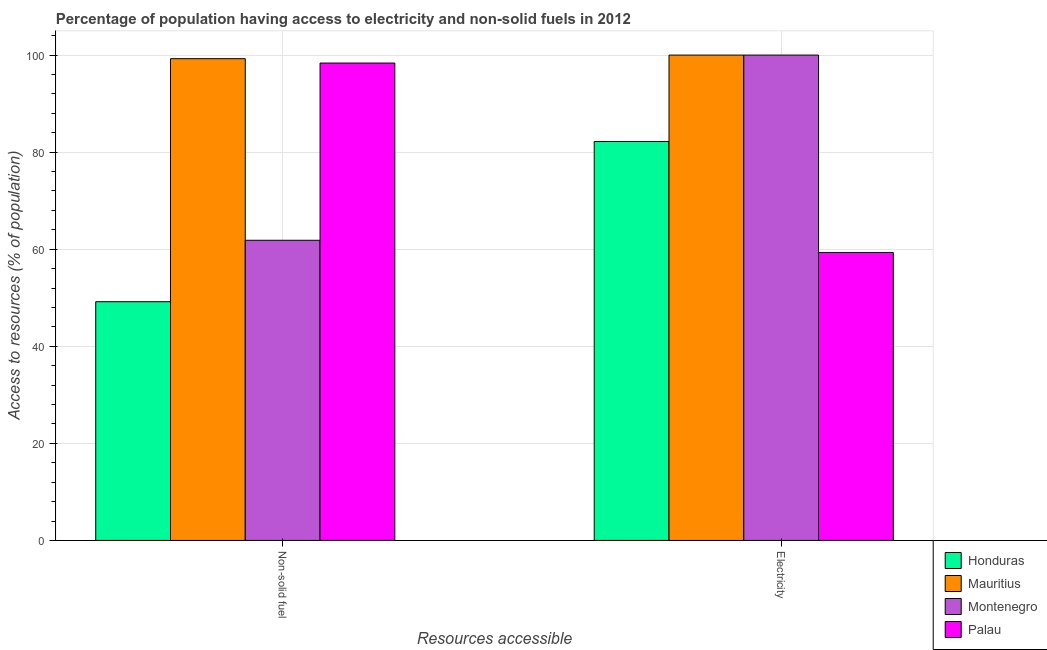How many groups of bars are there?
Give a very brief answer. 2. Are the number of bars per tick equal to the number of legend labels?
Offer a very short reply. Yes. Are the number of bars on each tick of the X-axis equal?
Your response must be concise. Yes. How many bars are there on the 1st tick from the right?
Ensure brevity in your answer.  4. What is the label of the 2nd group of bars from the left?
Your answer should be very brief. Electricity. What is the percentage of population having access to non-solid fuel in Honduras?
Ensure brevity in your answer.  49.19. Across all countries, what is the minimum percentage of population having access to electricity?
Make the answer very short. 59.33. In which country was the percentage of population having access to electricity maximum?
Offer a very short reply. Mauritius. In which country was the percentage of population having access to electricity minimum?
Give a very brief answer. Palau. What is the total percentage of population having access to electricity in the graph?
Make the answer very short. 341.53. What is the difference between the percentage of population having access to non-solid fuel in Montenegro and that in Honduras?
Your response must be concise. 12.66. What is the difference between the percentage of population having access to non-solid fuel in Palau and the percentage of population having access to electricity in Honduras?
Provide a succinct answer. 16.16. What is the average percentage of population having access to electricity per country?
Provide a short and direct response. 85.38. What is the difference between the percentage of population having access to non-solid fuel and percentage of population having access to electricity in Montenegro?
Provide a short and direct response. -38.15. What is the ratio of the percentage of population having access to non-solid fuel in Montenegro to that in Honduras?
Offer a terse response. 1.26. Is the percentage of population having access to electricity in Palau less than that in Mauritius?
Provide a short and direct response. Yes. What does the 1st bar from the left in Electricity represents?
Make the answer very short. Honduras. What does the 1st bar from the right in Non-solid fuel represents?
Your response must be concise. Palau. Are all the bars in the graph horizontal?
Your answer should be compact. No. Are the values on the major ticks of Y-axis written in scientific E-notation?
Offer a very short reply. No. How many legend labels are there?
Offer a very short reply. 4. What is the title of the graph?
Ensure brevity in your answer.  Percentage of population having access to electricity and non-solid fuels in 2012. Does "Middle income" appear as one of the legend labels in the graph?
Offer a very short reply. No. What is the label or title of the X-axis?
Ensure brevity in your answer.  Resources accessible. What is the label or title of the Y-axis?
Provide a short and direct response. Access to resources (% of population). What is the Access to resources (% of population) in Honduras in Non-solid fuel?
Your response must be concise. 49.19. What is the Access to resources (% of population) of Mauritius in Non-solid fuel?
Offer a terse response. 99.26. What is the Access to resources (% of population) of Montenegro in Non-solid fuel?
Provide a short and direct response. 61.85. What is the Access to resources (% of population) of Palau in Non-solid fuel?
Give a very brief answer. 98.36. What is the Access to resources (% of population) in Honduras in Electricity?
Provide a short and direct response. 82.2. What is the Access to resources (% of population) in Mauritius in Electricity?
Your response must be concise. 100. What is the Access to resources (% of population) of Palau in Electricity?
Offer a terse response. 59.33. Across all Resources accessible, what is the maximum Access to resources (% of population) of Honduras?
Provide a succinct answer. 82.2. Across all Resources accessible, what is the maximum Access to resources (% of population) in Mauritius?
Your answer should be very brief. 100. Across all Resources accessible, what is the maximum Access to resources (% of population) of Montenegro?
Offer a terse response. 100. Across all Resources accessible, what is the maximum Access to resources (% of population) in Palau?
Make the answer very short. 98.36. Across all Resources accessible, what is the minimum Access to resources (% of population) of Honduras?
Make the answer very short. 49.19. Across all Resources accessible, what is the minimum Access to resources (% of population) of Mauritius?
Give a very brief answer. 99.26. Across all Resources accessible, what is the minimum Access to resources (% of population) of Montenegro?
Your response must be concise. 61.85. Across all Resources accessible, what is the minimum Access to resources (% of population) in Palau?
Make the answer very short. 59.33. What is the total Access to resources (% of population) in Honduras in the graph?
Offer a terse response. 131.39. What is the total Access to resources (% of population) of Mauritius in the graph?
Offer a terse response. 199.26. What is the total Access to resources (% of population) of Montenegro in the graph?
Ensure brevity in your answer.  161.85. What is the total Access to resources (% of population) of Palau in the graph?
Your response must be concise. 157.69. What is the difference between the Access to resources (% of population) of Honduras in Non-solid fuel and that in Electricity?
Give a very brief answer. -33.01. What is the difference between the Access to resources (% of population) of Mauritius in Non-solid fuel and that in Electricity?
Make the answer very short. -0.74. What is the difference between the Access to resources (% of population) of Montenegro in Non-solid fuel and that in Electricity?
Offer a terse response. -38.15. What is the difference between the Access to resources (% of population) of Palau in Non-solid fuel and that in Electricity?
Keep it short and to the point. 39.03. What is the difference between the Access to resources (% of population) of Honduras in Non-solid fuel and the Access to resources (% of population) of Mauritius in Electricity?
Offer a very short reply. -50.81. What is the difference between the Access to resources (% of population) in Honduras in Non-solid fuel and the Access to resources (% of population) in Montenegro in Electricity?
Your answer should be very brief. -50.81. What is the difference between the Access to resources (% of population) in Honduras in Non-solid fuel and the Access to resources (% of population) in Palau in Electricity?
Your answer should be compact. -10.14. What is the difference between the Access to resources (% of population) in Mauritius in Non-solid fuel and the Access to resources (% of population) in Montenegro in Electricity?
Offer a very short reply. -0.74. What is the difference between the Access to resources (% of population) in Mauritius in Non-solid fuel and the Access to resources (% of population) in Palau in Electricity?
Ensure brevity in your answer.  39.93. What is the difference between the Access to resources (% of population) in Montenegro in Non-solid fuel and the Access to resources (% of population) in Palau in Electricity?
Provide a short and direct response. 2.52. What is the average Access to resources (% of population) of Honduras per Resources accessible?
Offer a very short reply. 65.69. What is the average Access to resources (% of population) in Mauritius per Resources accessible?
Ensure brevity in your answer.  99.63. What is the average Access to resources (% of population) in Montenegro per Resources accessible?
Your answer should be compact. 80.92. What is the average Access to resources (% of population) in Palau per Resources accessible?
Give a very brief answer. 78.84. What is the difference between the Access to resources (% of population) in Honduras and Access to resources (% of population) in Mauritius in Non-solid fuel?
Ensure brevity in your answer.  -50.07. What is the difference between the Access to resources (% of population) of Honduras and Access to resources (% of population) of Montenegro in Non-solid fuel?
Make the answer very short. -12.66. What is the difference between the Access to resources (% of population) of Honduras and Access to resources (% of population) of Palau in Non-solid fuel?
Provide a succinct answer. -49.17. What is the difference between the Access to resources (% of population) in Mauritius and Access to resources (% of population) in Montenegro in Non-solid fuel?
Provide a succinct answer. 37.41. What is the difference between the Access to resources (% of population) of Mauritius and Access to resources (% of population) of Palau in Non-solid fuel?
Give a very brief answer. 0.9. What is the difference between the Access to resources (% of population) of Montenegro and Access to resources (% of population) of Palau in Non-solid fuel?
Make the answer very short. -36.51. What is the difference between the Access to resources (% of population) of Honduras and Access to resources (% of population) of Mauritius in Electricity?
Give a very brief answer. -17.8. What is the difference between the Access to resources (% of population) in Honduras and Access to resources (% of population) in Montenegro in Electricity?
Ensure brevity in your answer.  -17.8. What is the difference between the Access to resources (% of population) in Honduras and Access to resources (% of population) in Palau in Electricity?
Offer a terse response. 22.87. What is the difference between the Access to resources (% of population) in Mauritius and Access to resources (% of population) in Palau in Electricity?
Your response must be concise. 40.67. What is the difference between the Access to resources (% of population) of Montenegro and Access to resources (% of population) of Palau in Electricity?
Provide a short and direct response. 40.67. What is the ratio of the Access to resources (% of population) of Honduras in Non-solid fuel to that in Electricity?
Keep it short and to the point. 0.6. What is the ratio of the Access to resources (% of population) of Montenegro in Non-solid fuel to that in Electricity?
Keep it short and to the point. 0.62. What is the ratio of the Access to resources (% of population) of Palau in Non-solid fuel to that in Electricity?
Keep it short and to the point. 1.66. What is the difference between the highest and the second highest Access to resources (% of population) of Honduras?
Your answer should be compact. 33.01. What is the difference between the highest and the second highest Access to resources (% of population) in Mauritius?
Ensure brevity in your answer.  0.74. What is the difference between the highest and the second highest Access to resources (% of population) in Montenegro?
Your response must be concise. 38.15. What is the difference between the highest and the second highest Access to resources (% of population) of Palau?
Provide a short and direct response. 39.03. What is the difference between the highest and the lowest Access to resources (% of population) in Honduras?
Give a very brief answer. 33.01. What is the difference between the highest and the lowest Access to resources (% of population) in Mauritius?
Offer a very short reply. 0.74. What is the difference between the highest and the lowest Access to resources (% of population) in Montenegro?
Give a very brief answer. 38.15. What is the difference between the highest and the lowest Access to resources (% of population) in Palau?
Keep it short and to the point. 39.03. 